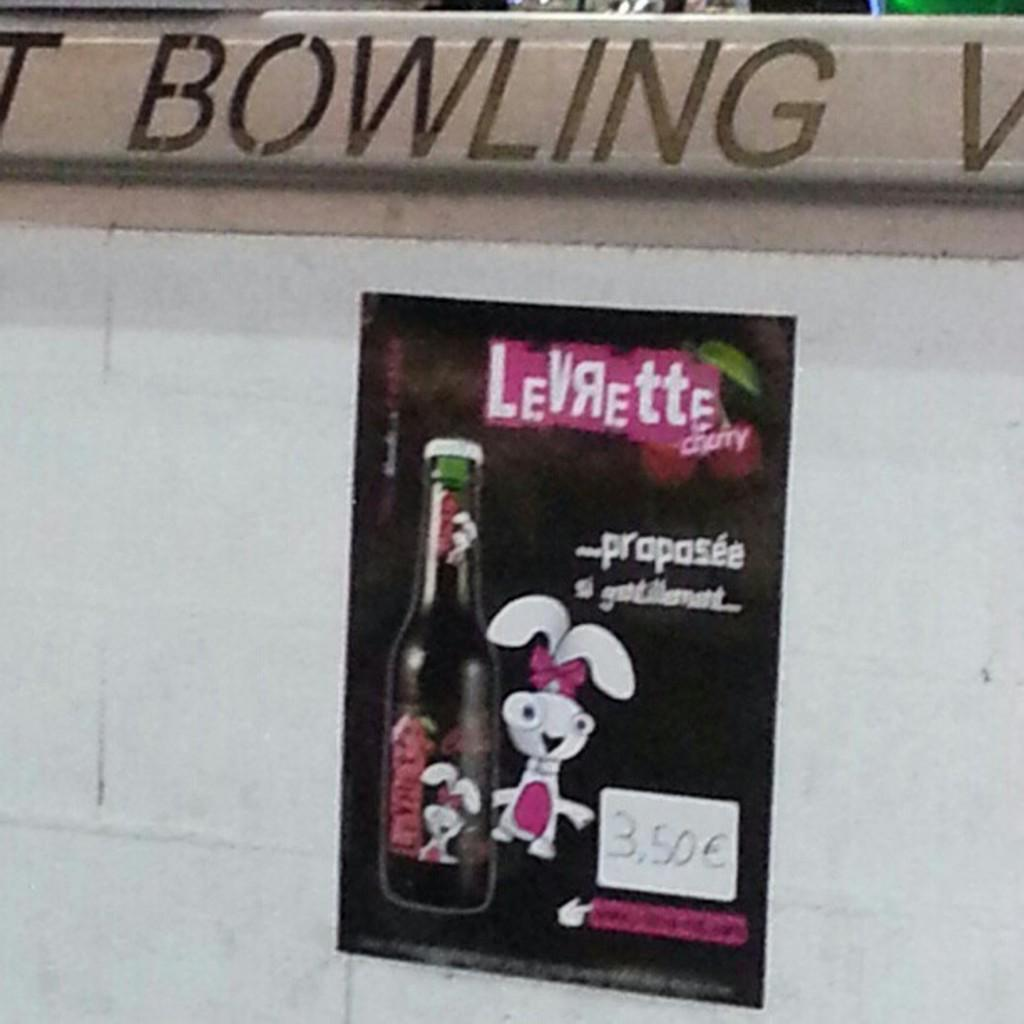<image>
Create a compact narrative representing the image presented. A Levrette sticker on a wall at a bowling alley. 